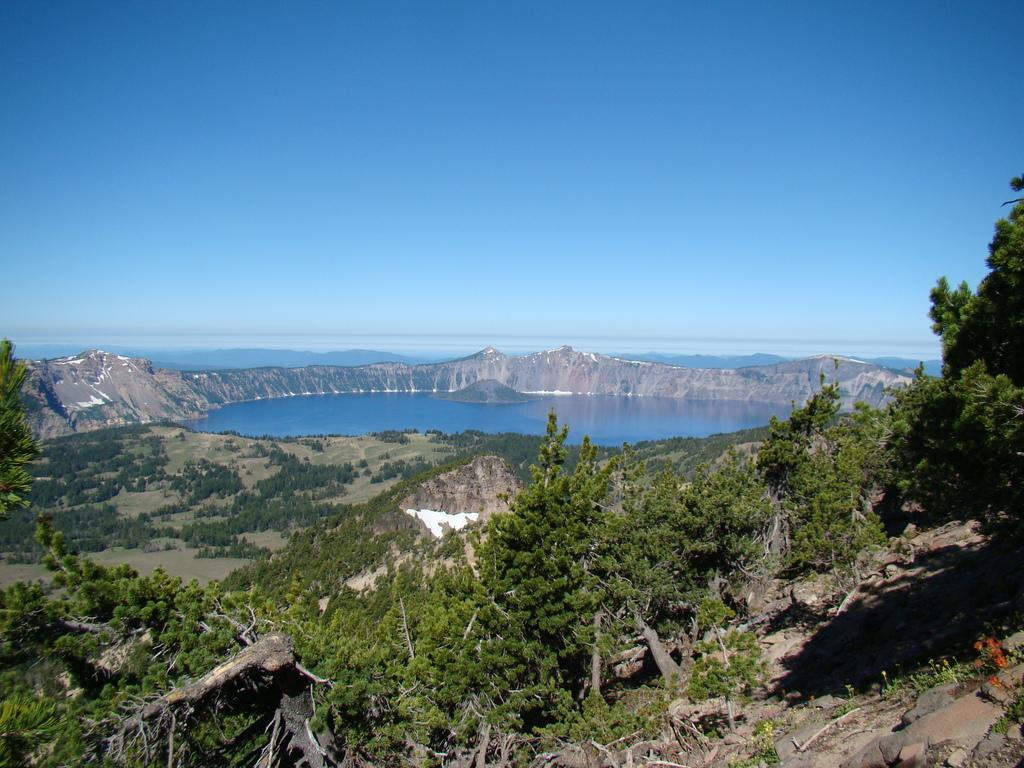What is the main feature of the image? The main feature of the image is water. What other natural elements can be seen in the image? There are mountains and trees in the image. What is visible at the top of the image? The sky is visible at the top of the image. Where is the baby attending the meeting in the image? There is no baby or meeting present in the image. What type of net is being used to catch fish in the image? There is no net or fishing activity depicted in the image. 